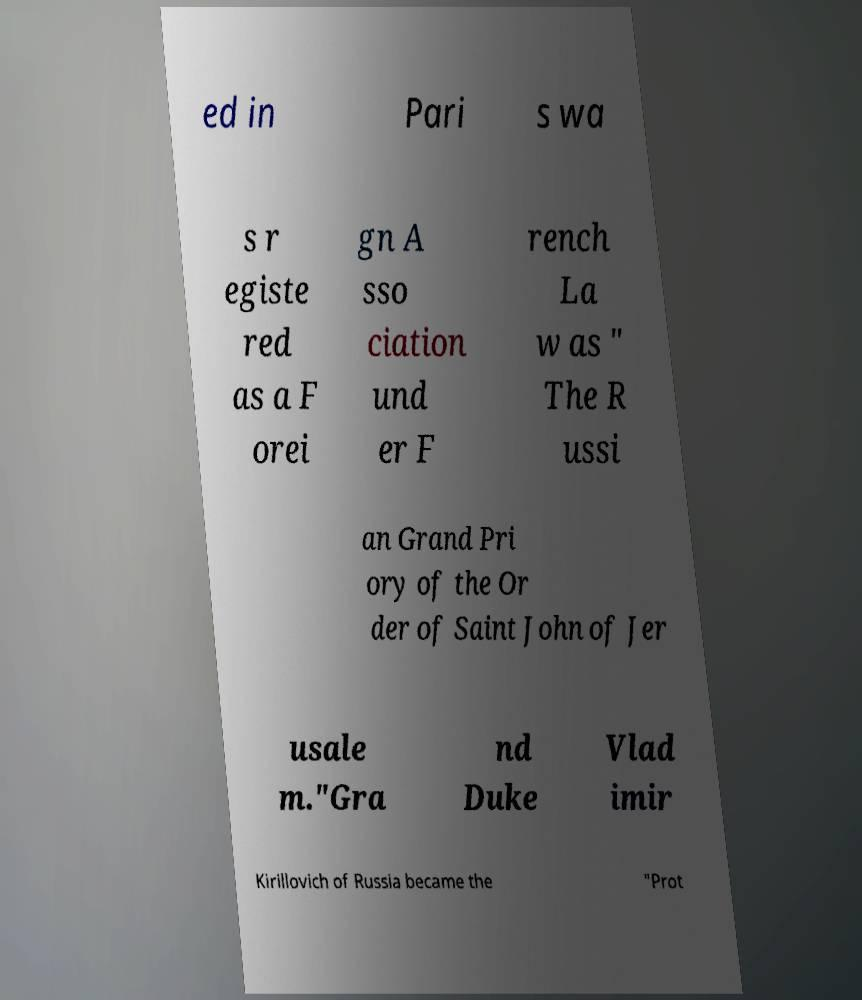Please read and relay the text visible in this image. What does it say? ed in Pari s wa s r egiste red as a F orei gn A sso ciation und er F rench La w as " The R ussi an Grand Pri ory of the Or der of Saint John of Jer usale m."Gra nd Duke Vlad imir Kirillovich of Russia became the "Prot 